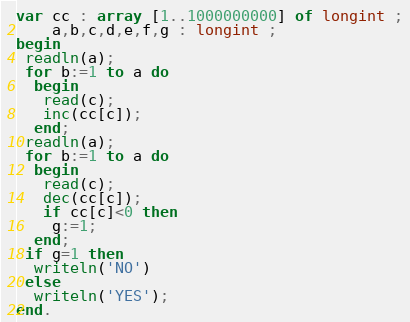Convert code to text. <code><loc_0><loc_0><loc_500><loc_500><_Pascal_>var cc : array [1..1000000000] of longint ;
    a,b,c,d,e,f,g : longint ;
begin
 readln(a);
 for b:=1 to a do
  begin
   read(c);
   inc(cc[c]);
  end;
 readln(a);
 for b:=1 to a do
  begin
   read(c);
   dec(cc[c]);
   if cc[c]<0 then
    g:=1;
  end;
 if g=1 then
  writeln('NO')
 else
  writeln('YES');
end.
</code> 